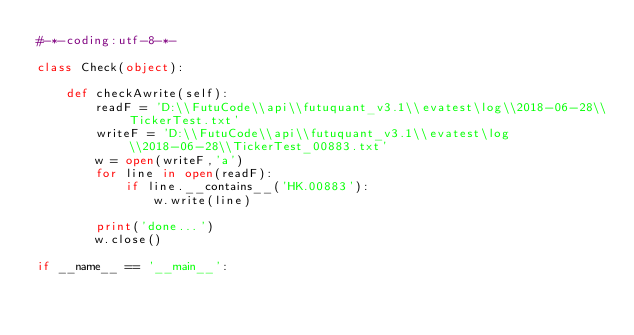<code> <loc_0><loc_0><loc_500><loc_500><_Python_>#-*-coding:utf-8-*-

class Check(object):

    def checkAwrite(self):
        readF = 'D:\\FutuCode\\api\\futuquant_v3.1\\evatest\log\\2018-06-28\\TickerTest.txt'
        writeF = 'D:\\FutuCode\\api\\futuquant_v3.1\\evatest\log\\2018-06-28\\TickerTest_00883.txt'
        w = open(writeF,'a')
        for line in open(readF):
            if line.__contains__('HK.00883'):
                w.write(line)

        print('done...')
        w.close()

if __name__ == '__main__':</code> 